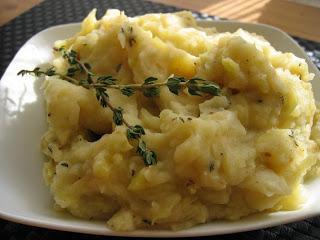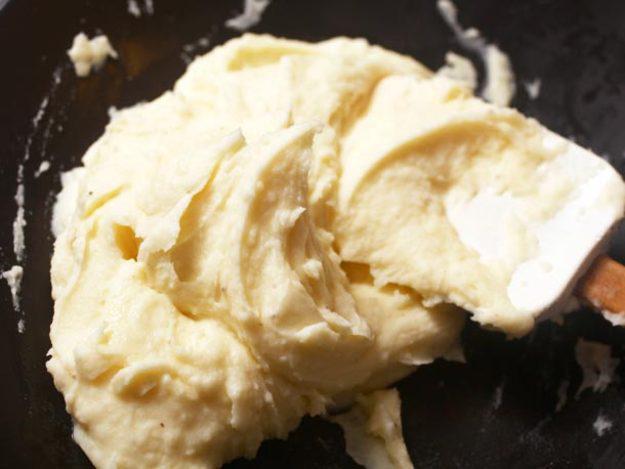The first image is the image on the left, the second image is the image on the right. Analyze the images presented: Is the assertion "the mashed potato on the right image is shaped like a bowl of gravy." valid? Answer yes or no. No. 